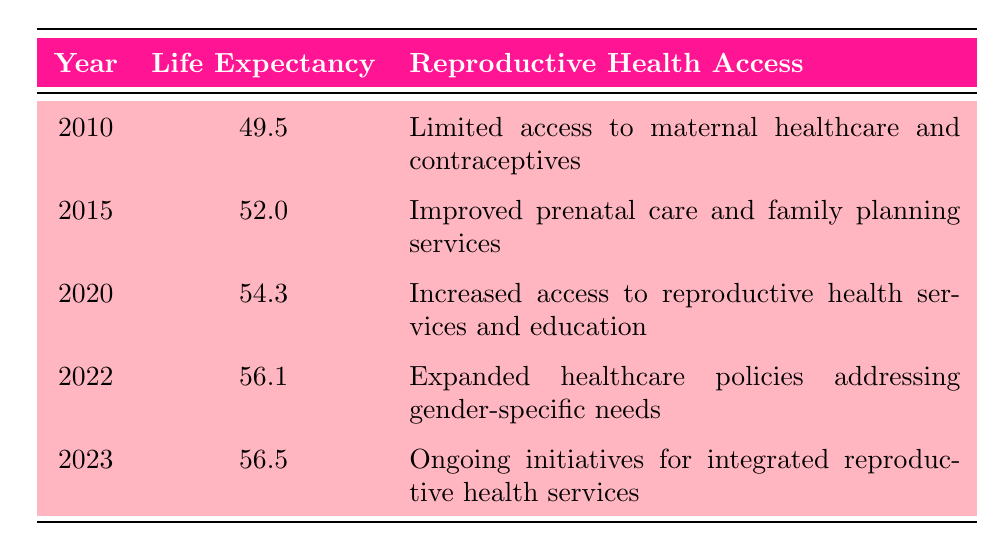What was the life expectancy of women in Swaziland in 2015? According to the table, the life expectancy for women in Swaziland in the year 2015 is listed as 52.0.
Answer: 52.0 What has been the trend in life expectancy from 2010 to 2023? By analyzing the table, we see that life expectancy increased from 49.5 in 2010 to 56.5 in 2023, indicating a positive trend over this time period.
Answer: Positive trend Is the statement "In 2020, reproductive health access improved significantly" true or false? The table shows that in 2020, there was increased access to reproductive health services and education, which suggests that there was indeed significant improvement in reproductive health access in that year.
Answer: True What is the difference in life expectancy between 2010 and 2022? The life expectancy in 2010 was 49.5 and in 2022 it was 56.1. To find the difference, we subtract: 56.1 - 49.5 = 6.6.
Answer: 6.6 What is the average life expectancy from 2010 to 2023? To find the average, we sum the life expectancy values: 49.5 + 52.0 + 54.3 + 56.1 + 56.5 = 268.4. There are 5 data points, so we divide by 5: 268.4 / 5 = 53.68.
Answer: 53.68 In which year did life expectancy increase the most compared to the previous year? Examining the table, the greatest increase occurs between 2022 and 2023 where life expectancy rose from 56.1 to 56.5, a difference of 0.4. Additionally, the increase between 2010 and 2015 (52.0 - 49.5 = 2.5) suggests smaller increases in prior years. Therefore, the largest increase is between 2022 and 2023.
Answer: 2022 to 2023 What reproductive health access improvements were made from 2015 to 2020? In 2015, women had improved prenatal care and family planning services. By 2020, access had increased to reproductive health services and education, suggesting greater overall improvement in several areas of reproductive health access from 2015 to 2020.
Answer: Increased access to reproductive health services and education How did reproductive health access change from 2010 to 2023? In 2010, access was limited to maternal healthcare and contraceptives, whereas by 2023, there were ongoing initiatives for integrated reproductive health services, indicating a significant enhancement across the years.
Answer: Significant enhancement 